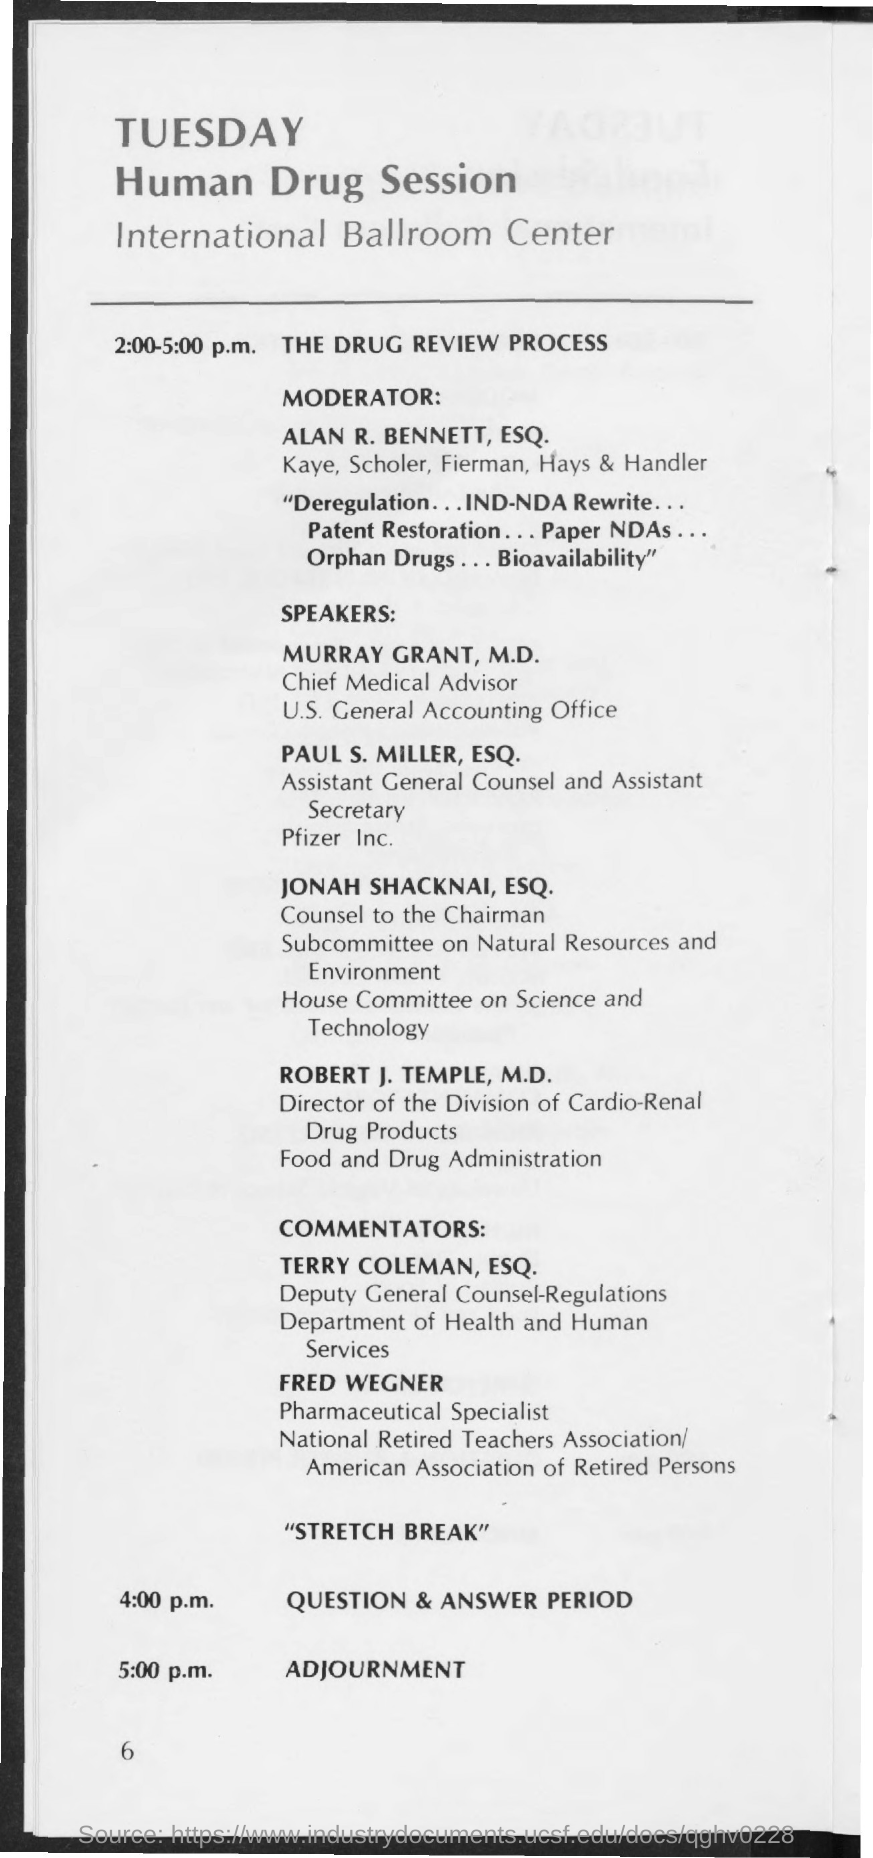Indicate a few pertinent items in this graphic. The name of the moderator of the Human Drug Session is ALAN R. BENNETT, ESQ. The topic scheduled from 2:00-5:00 p.m. is "The Drug Review Process. The Human Drug Session is scheduled for Tuesday. 